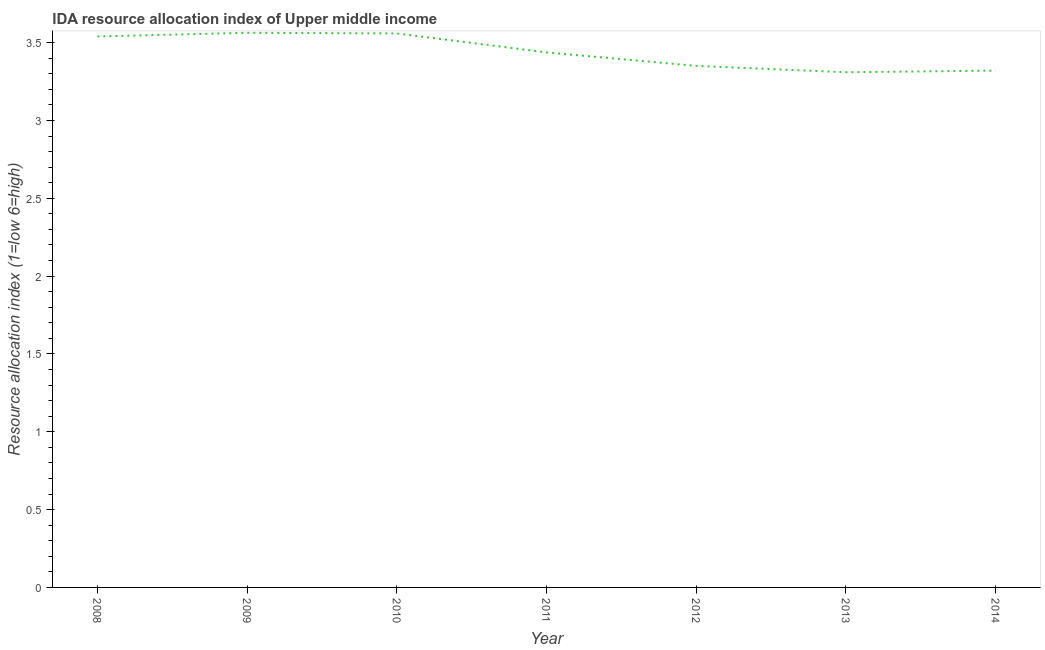What is the ida resource allocation index in 2014?
Give a very brief answer. 3.32. Across all years, what is the maximum ida resource allocation index?
Provide a succinct answer. 3.56. Across all years, what is the minimum ida resource allocation index?
Offer a terse response. 3.31. In which year was the ida resource allocation index maximum?
Make the answer very short. 2009. What is the sum of the ida resource allocation index?
Ensure brevity in your answer.  24.08. What is the difference between the ida resource allocation index in 2009 and 2010?
Provide a succinct answer. 0. What is the average ida resource allocation index per year?
Keep it short and to the point. 3.44. What is the median ida resource allocation index?
Your response must be concise. 3.44. In how many years, is the ida resource allocation index greater than 2.3 ?
Your answer should be compact. 7. What is the ratio of the ida resource allocation index in 2011 to that in 2014?
Your answer should be very brief. 1.04. Is the ida resource allocation index in 2009 less than that in 2012?
Your response must be concise. No. What is the difference between the highest and the second highest ida resource allocation index?
Your answer should be very brief. 0. What is the difference between the highest and the lowest ida resource allocation index?
Your answer should be very brief. 0.25. Does the ida resource allocation index monotonically increase over the years?
Provide a short and direct response. No. How many years are there in the graph?
Keep it short and to the point. 7. Are the values on the major ticks of Y-axis written in scientific E-notation?
Your answer should be compact. No. Does the graph contain any zero values?
Your answer should be compact. No. Does the graph contain grids?
Your response must be concise. No. What is the title of the graph?
Make the answer very short. IDA resource allocation index of Upper middle income. What is the label or title of the Y-axis?
Ensure brevity in your answer.  Resource allocation index (1=low 6=high). What is the Resource allocation index (1=low 6=high) of 2008?
Make the answer very short. 3.54. What is the Resource allocation index (1=low 6=high) of 2009?
Keep it short and to the point. 3.56. What is the Resource allocation index (1=low 6=high) in 2010?
Offer a terse response. 3.56. What is the Resource allocation index (1=low 6=high) of 2011?
Make the answer very short. 3.44. What is the Resource allocation index (1=low 6=high) in 2012?
Offer a terse response. 3.35. What is the Resource allocation index (1=low 6=high) of 2013?
Offer a very short reply. 3.31. What is the Resource allocation index (1=low 6=high) in 2014?
Make the answer very short. 3.32. What is the difference between the Resource allocation index (1=low 6=high) in 2008 and 2009?
Your answer should be very brief. -0.02. What is the difference between the Resource allocation index (1=low 6=high) in 2008 and 2010?
Keep it short and to the point. -0.02. What is the difference between the Resource allocation index (1=low 6=high) in 2008 and 2011?
Keep it short and to the point. 0.1. What is the difference between the Resource allocation index (1=low 6=high) in 2008 and 2012?
Your answer should be compact. 0.19. What is the difference between the Resource allocation index (1=low 6=high) in 2008 and 2013?
Provide a short and direct response. 0.23. What is the difference between the Resource allocation index (1=low 6=high) in 2008 and 2014?
Your answer should be compact. 0.22. What is the difference between the Resource allocation index (1=low 6=high) in 2009 and 2010?
Your answer should be very brief. 0. What is the difference between the Resource allocation index (1=low 6=high) in 2009 and 2011?
Ensure brevity in your answer.  0.13. What is the difference between the Resource allocation index (1=low 6=high) in 2009 and 2012?
Ensure brevity in your answer.  0.21. What is the difference between the Resource allocation index (1=low 6=high) in 2009 and 2013?
Offer a very short reply. 0.25. What is the difference between the Resource allocation index (1=low 6=high) in 2009 and 2014?
Offer a terse response. 0.24. What is the difference between the Resource allocation index (1=low 6=high) in 2010 and 2011?
Provide a succinct answer. 0.12. What is the difference between the Resource allocation index (1=low 6=high) in 2010 and 2012?
Provide a short and direct response. 0.21. What is the difference between the Resource allocation index (1=low 6=high) in 2010 and 2013?
Ensure brevity in your answer.  0.25. What is the difference between the Resource allocation index (1=low 6=high) in 2010 and 2014?
Make the answer very short. 0.24. What is the difference between the Resource allocation index (1=low 6=high) in 2011 and 2012?
Your response must be concise. 0.09. What is the difference between the Resource allocation index (1=low 6=high) in 2011 and 2013?
Your response must be concise. 0.13. What is the difference between the Resource allocation index (1=low 6=high) in 2011 and 2014?
Keep it short and to the point. 0.12. What is the difference between the Resource allocation index (1=low 6=high) in 2012 and 2013?
Offer a terse response. 0.04. What is the difference between the Resource allocation index (1=low 6=high) in 2012 and 2014?
Ensure brevity in your answer.  0.03. What is the difference between the Resource allocation index (1=low 6=high) in 2013 and 2014?
Provide a succinct answer. -0.01. What is the ratio of the Resource allocation index (1=low 6=high) in 2008 to that in 2009?
Provide a short and direct response. 0.99. What is the ratio of the Resource allocation index (1=low 6=high) in 2008 to that in 2012?
Offer a terse response. 1.06. What is the ratio of the Resource allocation index (1=low 6=high) in 2008 to that in 2013?
Provide a succinct answer. 1.07. What is the ratio of the Resource allocation index (1=low 6=high) in 2008 to that in 2014?
Offer a terse response. 1.07. What is the ratio of the Resource allocation index (1=low 6=high) in 2009 to that in 2012?
Make the answer very short. 1.06. What is the ratio of the Resource allocation index (1=low 6=high) in 2009 to that in 2013?
Provide a succinct answer. 1.08. What is the ratio of the Resource allocation index (1=low 6=high) in 2009 to that in 2014?
Ensure brevity in your answer.  1.07. What is the ratio of the Resource allocation index (1=low 6=high) in 2010 to that in 2011?
Give a very brief answer. 1.03. What is the ratio of the Resource allocation index (1=low 6=high) in 2010 to that in 2012?
Your response must be concise. 1.06. What is the ratio of the Resource allocation index (1=low 6=high) in 2010 to that in 2013?
Your response must be concise. 1.07. What is the ratio of the Resource allocation index (1=low 6=high) in 2010 to that in 2014?
Ensure brevity in your answer.  1.07. What is the ratio of the Resource allocation index (1=low 6=high) in 2011 to that in 2013?
Ensure brevity in your answer.  1.04. What is the ratio of the Resource allocation index (1=low 6=high) in 2011 to that in 2014?
Keep it short and to the point. 1.03. 